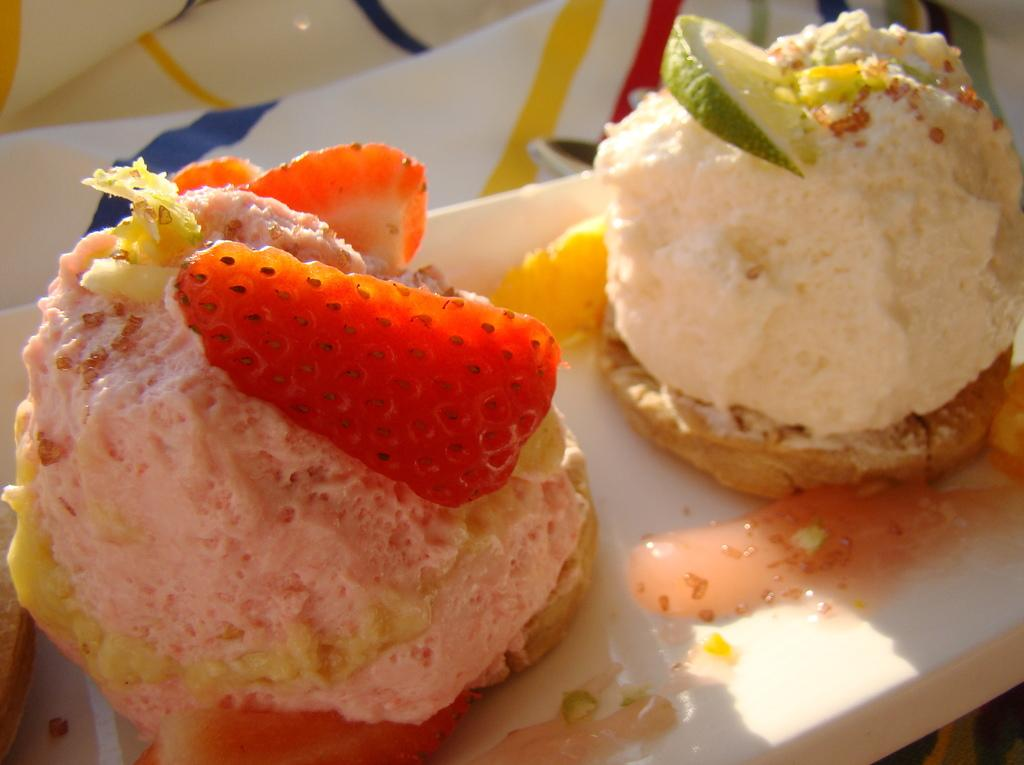What is present in the image? There is food in the image. What type of oil can be seen dripping from the food in the image? There is no oil present in the image, and the food is not depicted as dripping anything. 